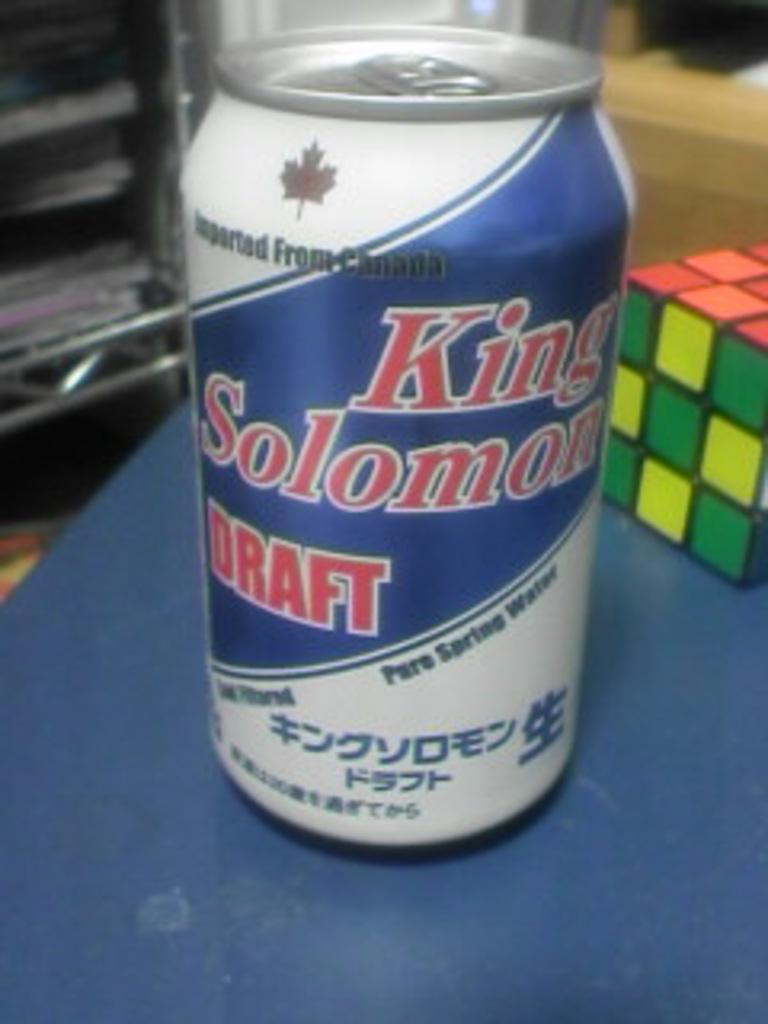What is the main object in the image? There is a cube in the image. Where is the cube located? The cube is placed on a table. How many chickens are sitting on the cube in the image? There are no chickens present in the image; it only features a cube placed on a table. 